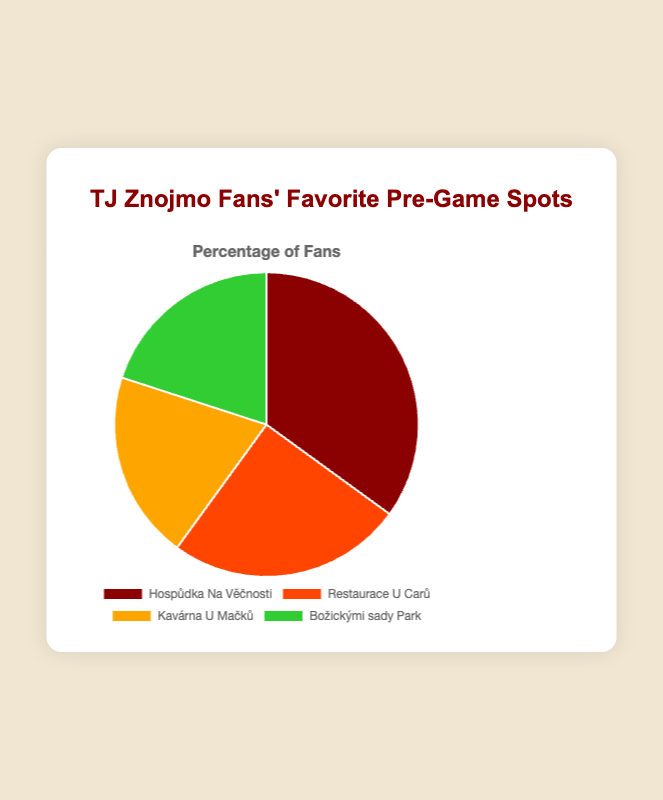Which local spot has the highest percentage of TJ Znojmo fans for pre-game gatherings? The spot with the highest percentage of fans is indicated by the largest segment in the pie chart. "Hospůdka Na Věčnosti" has the largest segment, representing 35%.
Answer: Hospůdka Na Věčnosti Which two spots have equal percentages of fans? Look for segments with the same visual size and percentage value. "Kavárna U Mačků" and "Božickými sady Park" each have segments representing 20%.
Answer: Kavárna U Mačků and Božickými sady Park How much higher in percentage is Hospůdka Na Věčnosti compared to Restaurace U Carů? Subtract the percentage of "Restaurace U Carů" from that of "Hospůdka Na Věčnosti". 35% - 25% = 10%.
Answer: 10% What is the combined percentage of fans for the two least popular pre-game spots? Identify the two spots with the smallest percentage values, then add their percentages. "Kavárna U Mačků" and "Božickými sady Park" each represent 20%, so 20% + 20% = 40%.
Answer: 40% Which spot has a percentage exactly halfway between the highest and lowest percentages? First, note the highest percentage (35%) and the lowest (20%). Then calculate the halfway point: (35% + 20%) / 2 = 27.5%. Compare this to the given percentages — none fit exactly.
Answer: None What is the difference in percentage between the most popular and least popular spots? Subtract the smallest percentage from the largest. 35% (Hospůdka Na Věčnosti) - 20% (Kavárna U Mačků or Božickými sady Park) = 15%.
Answer: 15% If you combine the percentages for pubs and parks, what is the total? Sum the percentages of "Hospůdka Na Věčnosti" and "Božickými sady Park". 35% (pub) + 20% (park) = 55%.
Answer: 55% Which spot has the third largest percentage of fans? Order the percentages from largest to smallest: 35%, 25%, 20%, 20%. The third largest is 20% shared by "Kavárna U Mačků" or "Božickými sady Park".
Answer: Kavárna U Mačků or Božickými sady Park 